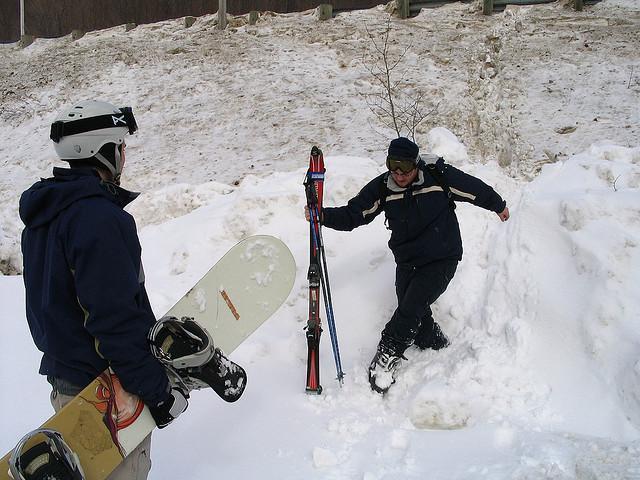How many people are visible?
Give a very brief answer. 2. 